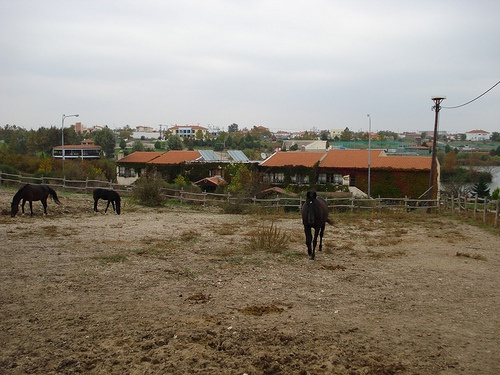Describe the objects in this image and their specific colors. I can see horse in lightgray, black, and gray tones, horse in lightgray, black, and gray tones, and horse in lightgray, black, and gray tones in this image. 